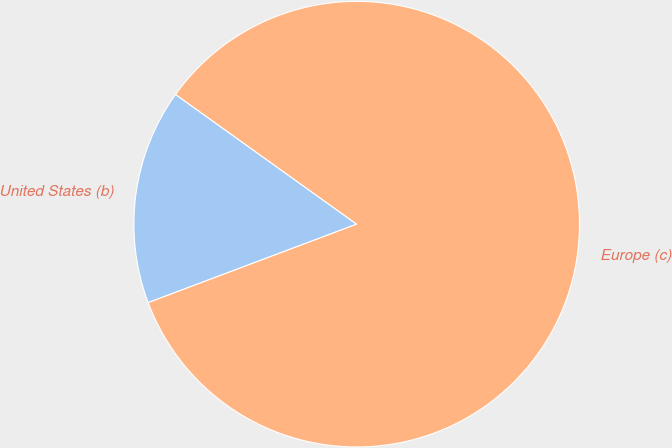Convert chart to OTSL. <chart><loc_0><loc_0><loc_500><loc_500><pie_chart><fcel>United States (b)<fcel>Europe (c)<nl><fcel>15.62%<fcel>84.38%<nl></chart> 